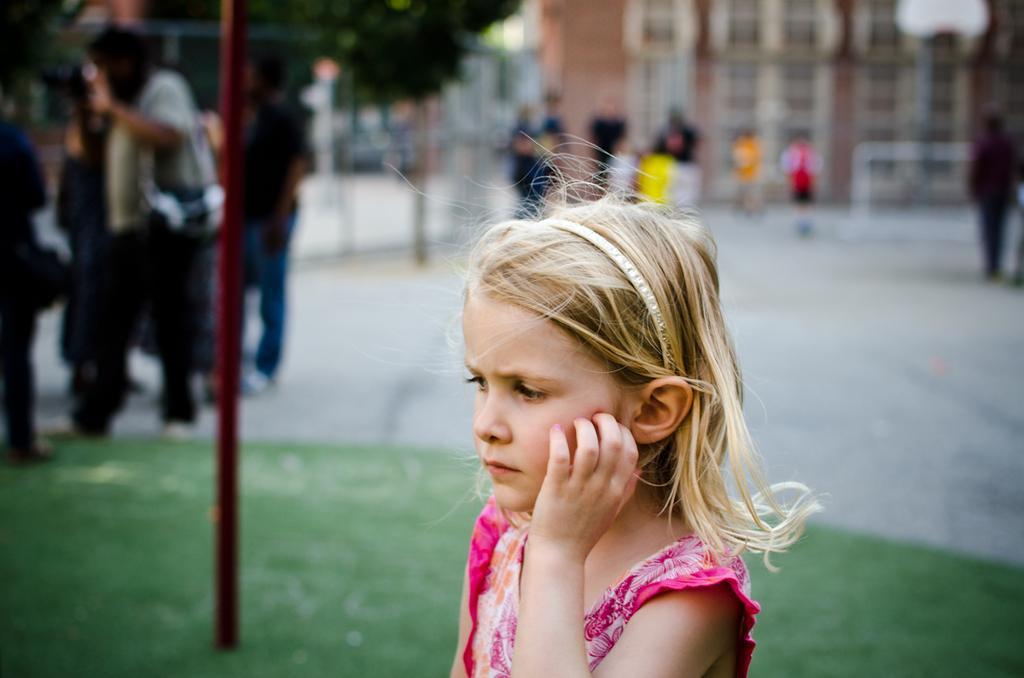How would you summarize this image in a sentence or two? In this picture I can see a girl is wearing pink color dress. In the background in people, places and buildings. I can also see trees. 